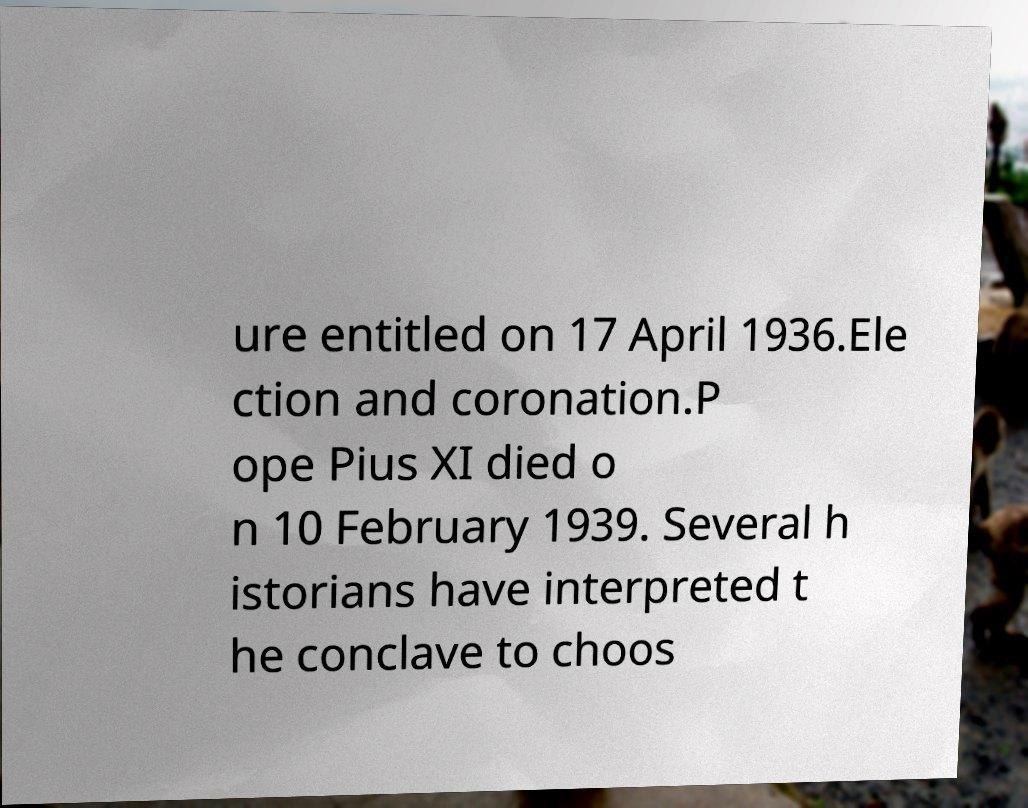For documentation purposes, I need the text within this image transcribed. Could you provide that? ure entitled on 17 April 1936.Ele ction and coronation.P ope Pius XI died o n 10 February 1939. Several h istorians have interpreted t he conclave to choos 